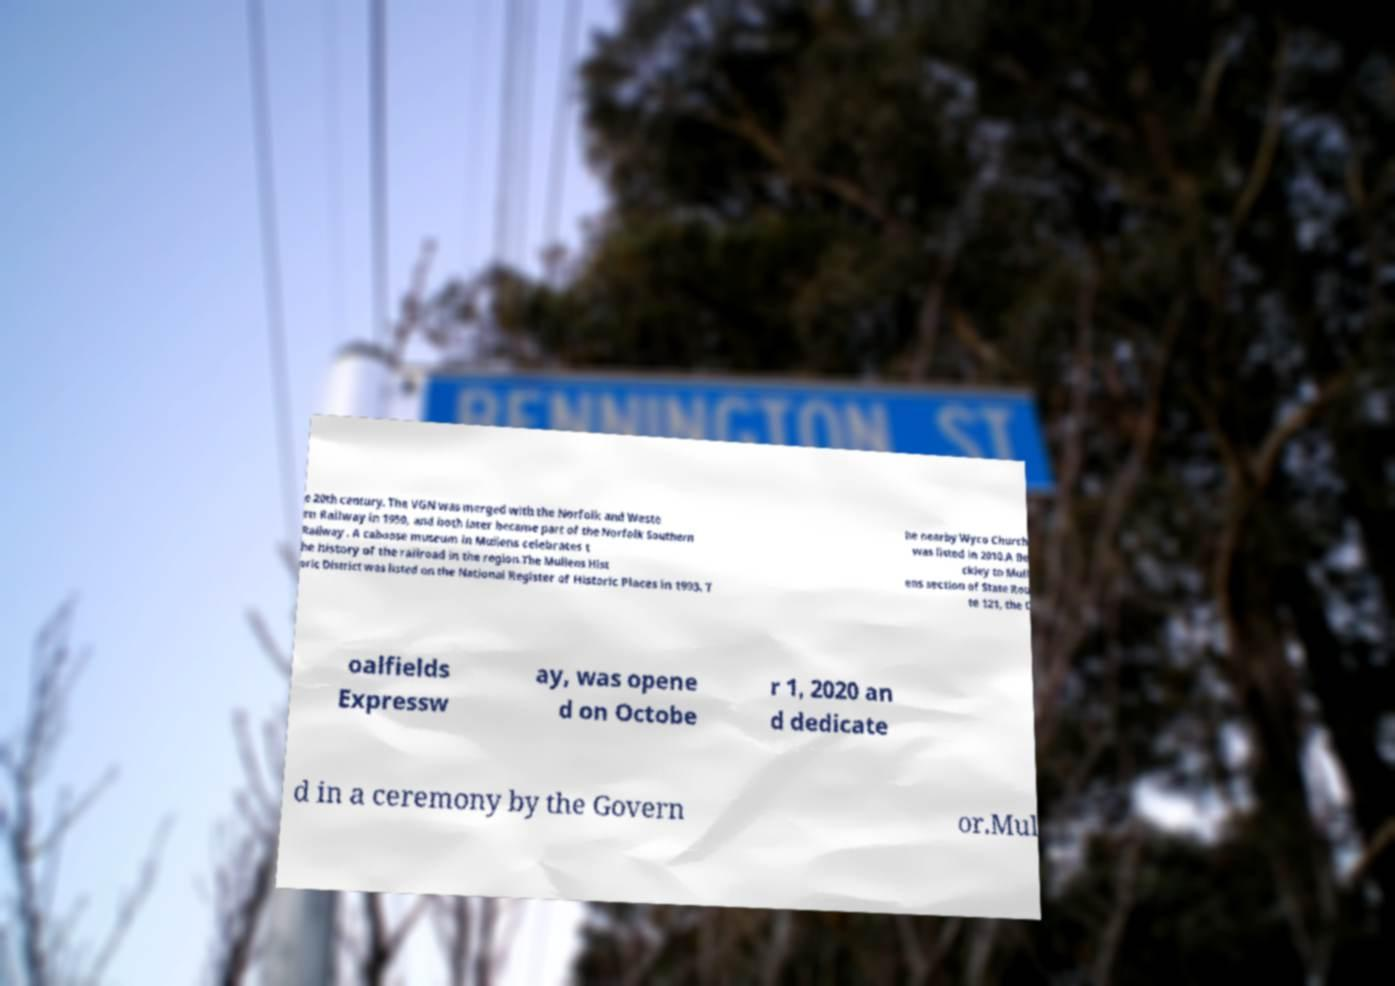Please read and relay the text visible in this image. What does it say? e 20th century. The VGN was merged with the Norfolk and Weste rn Railway in 1959, and both later became part of the Norfolk Southern Railway . A caboose museum in Mullens celebrates t he history of the railroad in the region.The Mullens Hist oric District was listed on the National Register of Historic Places in 1993. T he nearby Wyco Church was listed in 2010.A Be ckley to Mull ens section of State Rou te 121, the C oalfields Expressw ay, was opene d on Octobe r 1, 2020 an d dedicate d in a ceremony by the Govern or.Mul 